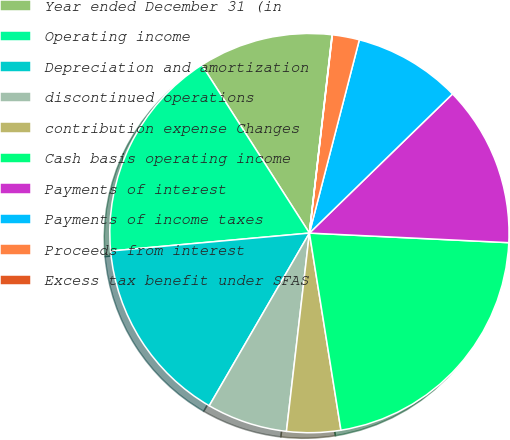Convert chart to OTSL. <chart><loc_0><loc_0><loc_500><loc_500><pie_chart><fcel>Year ended December 31 (in<fcel>Operating income<fcel>Depreciation and amortization<fcel>discontinued operations<fcel>contribution expense Changes<fcel>Cash basis operating income<fcel>Payments of interest<fcel>Payments of income taxes<fcel>Proceeds from interest<fcel>Excess tax benefit under SFAS<nl><fcel>10.87%<fcel>17.37%<fcel>15.2%<fcel>6.53%<fcel>4.36%<fcel>21.71%<fcel>13.04%<fcel>8.7%<fcel>2.19%<fcel>0.02%<nl></chart> 